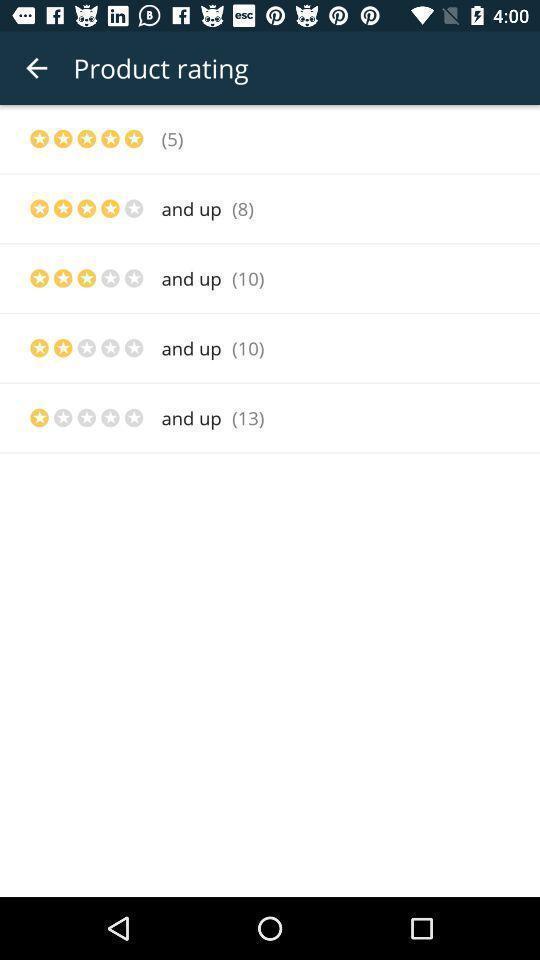Summarize the main components in this picture. Stars and values are showing to rate the product. 